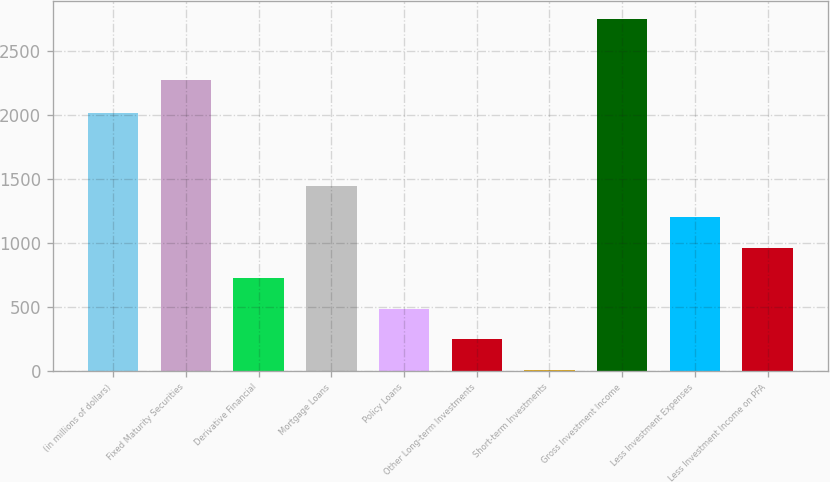Convert chart. <chart><loc_0><loc_0><loc_500><loc_500><bar_chart><fcel>(in millions of dollars)<fcel>Fixed Maturity Securities<fcel>Derivative Financial<fcel>Mortgage Loans<fcel>Policy Loans<fcel>Other Long-term Investments<fcel>Short-term Investments<fcel>Gross Investment Income<fcel>Less Investment Expenses<fcel>Less Investment Income on PFA<nl><fcel>2009<fcel>2268.5<fcel>722.97<fcel>1439.04<fcel>484.28<fcel>245.59<fcel>6.9<fcel>2745.88<fcel>1200.35<fcel>961.66<nl></chart> 